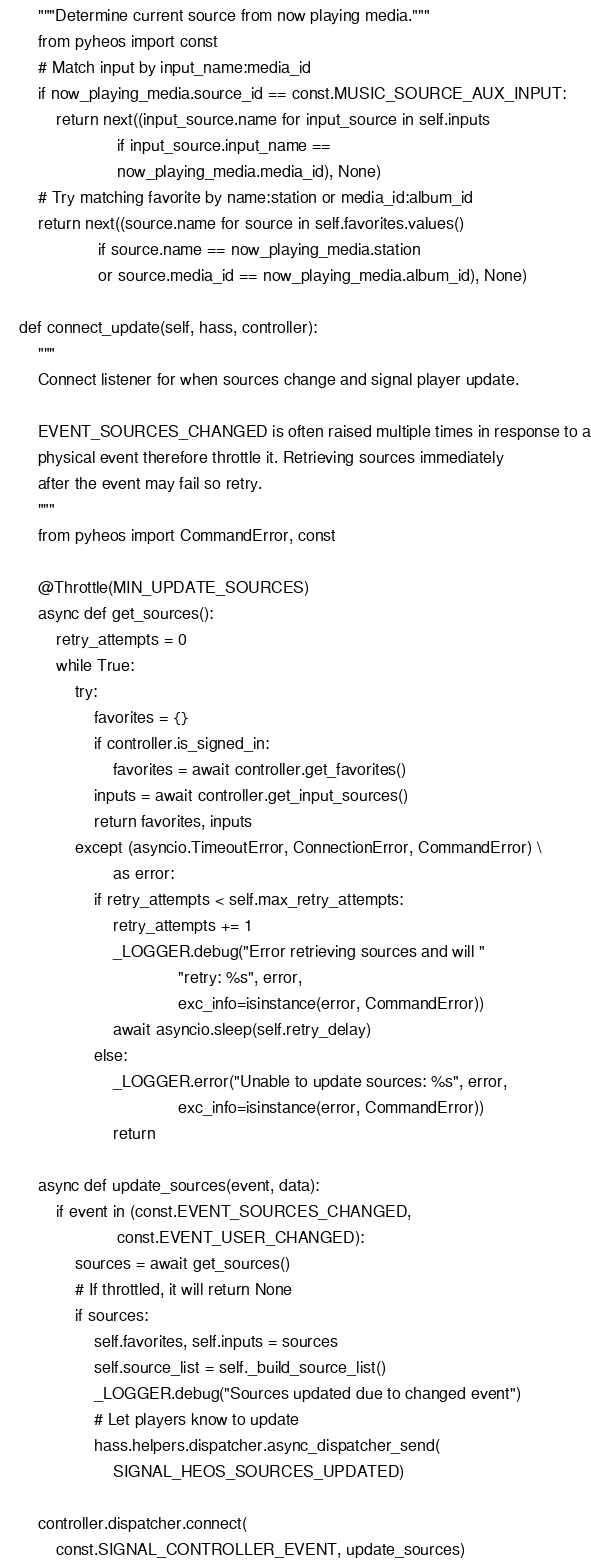<code> <loc_0><loc_0><loc_500><loc_500><_Python_>        """Determine current source from now playing media."""
        from pyheos import const
        # Match input by input_name:media_id
        if now_playing_media.source_id == const.MUSIC_SOURCE_AUX_INPUT:
            return next((input_source.name for input_source in self.inputs
                         if input_source.input_name ==
                         now_playing_media.media_id), None)
        # Try matching favorite by name:station or media_id:album_id
        return next((source.name for source in self.favorites.values()
                     if source.name == now_playing_media.station
                     or source.media_id == now_playing_media.album_id), None)

    def connect_update(self, hass, controller):
        """
        Connect listener for when sources change and signal player update.

        EVENT_SOURCES_CHANGED is often raised multiple times in response to a
        physical event therefore throttle it. Retrieving sources immediately
        after the event may fail so retry.
        """
        from pyheos import CommandError, const

        @Throttle(MIN_UPDATE_SOURCES)
        async def get_sources():
            retry_attempts = 0
            while True:
                try:
                    favorites = {}
                    if controller.is_signed_in:
                        favorites = await controller.get_favorites()
                    inputs = await controller.get_input_sources()
                    return favorites, inputs
                except (asyncio.TimeoutError, ConnectionError, CommandError) \
                        as error:
                    if retry_attempts < self.max_retry_attempts:
                        retry_attempts += 1
                        _LOGGER.debug("Error retrieving sources and will "
                                      "retry: %s", error,
                                      exc_info=isinstance(error, CommandError))
                        await asyncio.sleep(self.retry_delay)
                    else:
                        _LOGGER.error("Unable to update sources: %s", error,
                                      exc_info=isinstance(error, CommandError))
                        return

        async def update_sources(event, data):
            if event in (const.EVENT_SOURCES_CHANGED,
                         const.EVENT_USER_CHANGED):
                sources = await get_sources()
                # If throttled, it will return None
                if sources:
                    self.favorites, self.inputs = sources
                    self.source_list = self._build_source_list()
                    _LOGGER.debug("Sources updated due to changed event")
                    # Let players know to update
                    hass.helpers.dispatcher.async_dispatcher_send(
                        SIGNAL_HEOS_SOURCES_UPDATED)

        controller.dispatcher.connect(
            const.SIGNAL_CONTROLLER_EVENT, update_sources)
</code> 